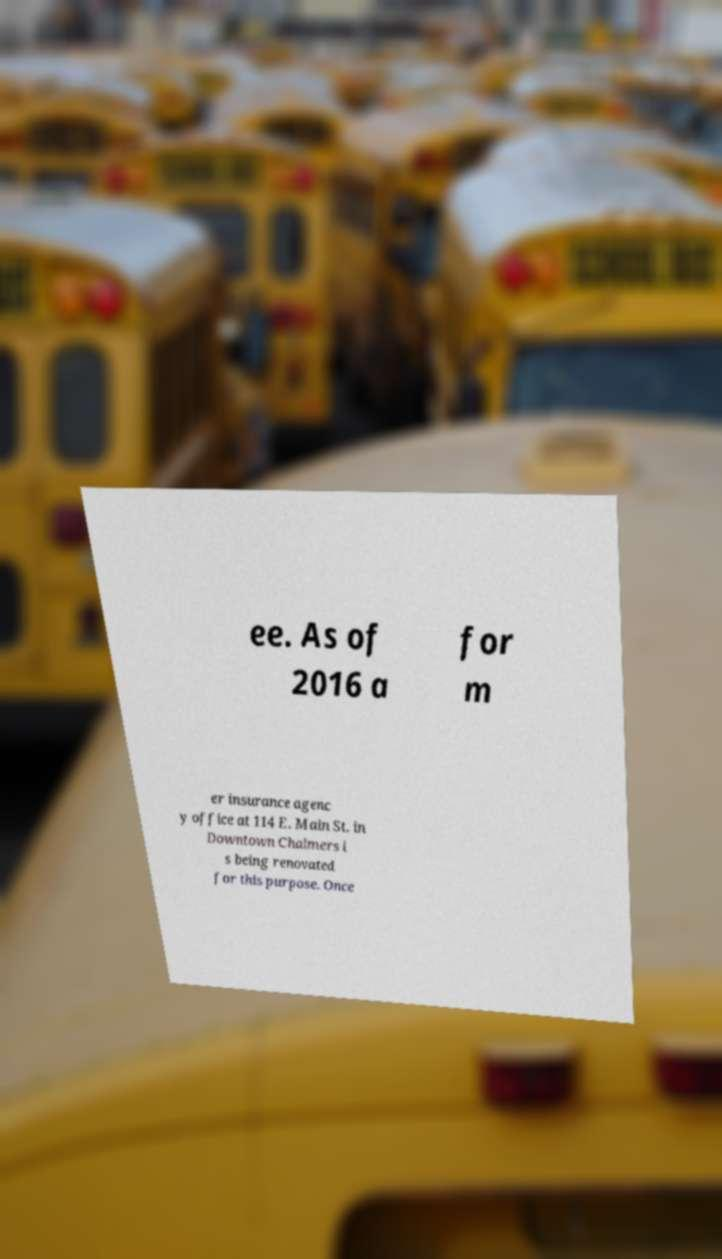Please identify and transcribe the text found in this image. ee. As of 2016 a for m er insurance agenc y office at 114 E. Main St. in Downtown Chalmers i s being renovated for this purpose. Once 